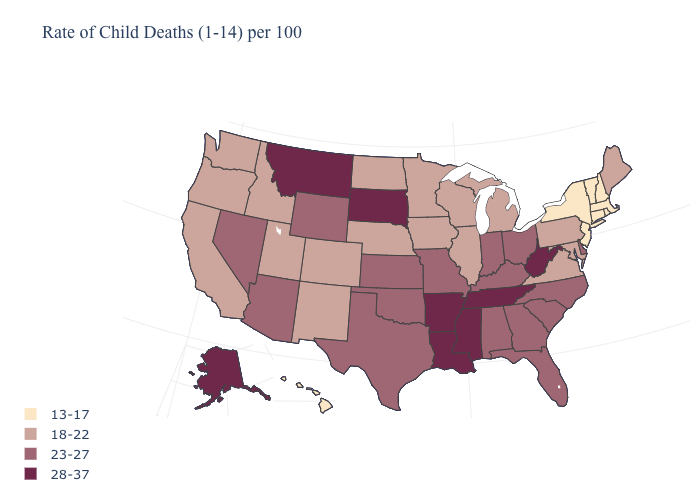Does the map have missing data?
Quick response, please. No. Is the legend a continuous bar?
Short answer required. No. What is the value of Alabama?
Be succinct. 23-27. Among the states that border Arkansas , does Tennessee have the lowest value?
Quick response, please. No. Name the states that have a value in the range 13-17?
Quick response, please. Connecticut, Hawaii, Massachusetts, New Hampshire, New Jersey, New York, Rhode Island, Vermont. How many symbols are there in the legend?
Give a very brief answer. 4. What is the value of Washington?
Give a very brief answer. 18-22. Name the states that have a value in the range 13-17?
Concise answer only. Connecticut, Hawaii, Massachusetts, New Hampshire, New Jersey, New York, Rhode Island, Vermont. What is the value of Utah?
Answer briefly. 18-22. Name the states that have a value in the range 28-37?
Short answer required. Alaska, Arkansas, Louisiana, Mississippi, Montana, South Dakota, Tennessee, West Virginia. What is the lowest value in the USA?
Answer briefly. 13-17. Is the legend a continuous bar?
Write a very short answer. No. Which states have the lowest value in the South?
Give a very brief answer. Maryland, Virginia. Which states have the lowest value in the USA?
Be succinct. Connecticut, Hawaii, Massachusetts, New Hampshire, New Jersey, New York, Rhode Island, Vermont. Does Hawaii have a lower value than New York?
Be succinct. No. 